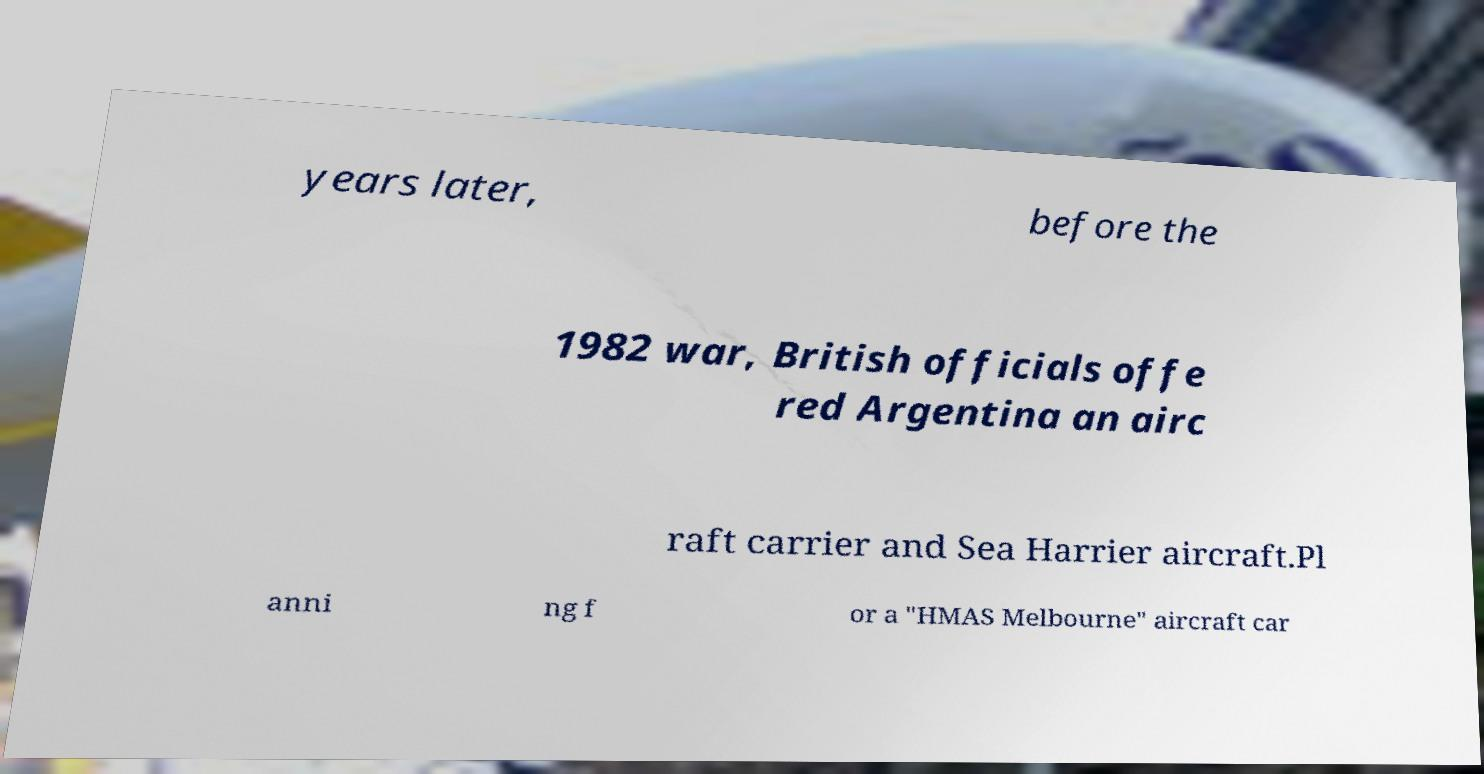Please read and relay the text visible in this image. What does it say? years later, before the 1982 war, British officials offe red Argentina an airc raft carrier and Sea Harrier aircraft.Pl anni ng f or a "HMAS Melbourne" aircraft car 